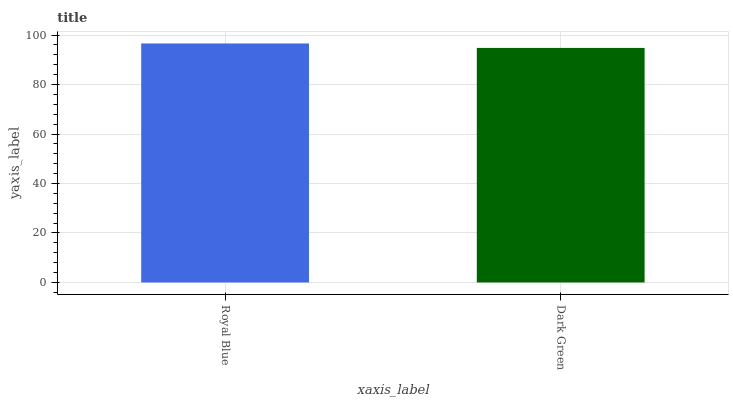Is Dark Green the minimum?
Answer yes or no. Yes. Is Royal Blue the maximum?
Answer yes or no. Yes. Is Dark Green the maximum?
Answer yes or no. No. Is Royal Blue greater than Dark Green?
Answer yes or no. Yes. Is Dark Green less than Royal Blue?
Answer yes or no. Yes. Is Dark Green greater than Royal Blue?
Answer yes or no. No. Is Royal Blue less than Dark Green?
Answer yes or no. No. Is Royal Blue the high median?
Answer yes or no. Yes. Is Dark Green the low median?
Answer yes or no. Yes. Is Dark Green the high median?
Answer yes or no. No. Is Royal Blue the low median?
Answer yes or no. No. 